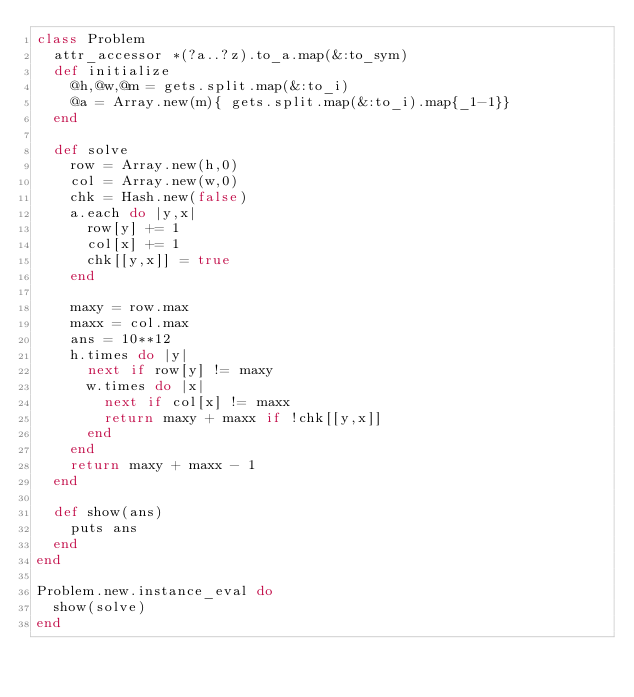Convert code to text. <code><loc_0><loc_0><loc_500><loc_500><_Ruby_>class Problem
  attr_accessor *(?a..?z).to_a.map(&:to_sym)
  def initialize
    @h,@w,@m = gets.split.map(&:to_i)
    @a = Array.new(m){ gets.split.map(&:to_i).map{_1-1}}
  end

  def solve
    row = Array.new(h,0)
    col = Array.new(w,0)
    chk = Hash.new(false)
    a.each do |y,x|
      row[y] += 1
      col[x] += 1
      chk[[y,x]] = true
    end

    maxy = row.max
    maxx = col.max
    ans = 10**12
    h.times do |y|
      next if row[y] != maxy
      w.times do |x|
        next if col[x] != maxx
        return maxy + maxx if !chk[[y,x]]
      end
    end
    return maxy + maxx - 1
  end

  def show(ans)
    puts ans
  end
end

Problem.new.instance_eval do
  show(solve)
end</code> 